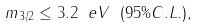<formula> <loc_0><loc_0><loc_500><loc_500>m _ { 3 / 2 } \leq 3 . 2 \ e V \ ( 9 5 \% C . L . ) ,</formula> 